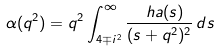Convert formula to latex. <formula><loc_0><loc_0><loc_500><loc_500>\alpha ( q ^ { 2 } ) = q ^ { 2 } \int _ { 4 \mp i ^ { 2 } } ^ { \infty } \frac { \ h a { } ( s ) } { ( s + q ^ { 2 } ) ^ { 2 } } \, d s</formula> 